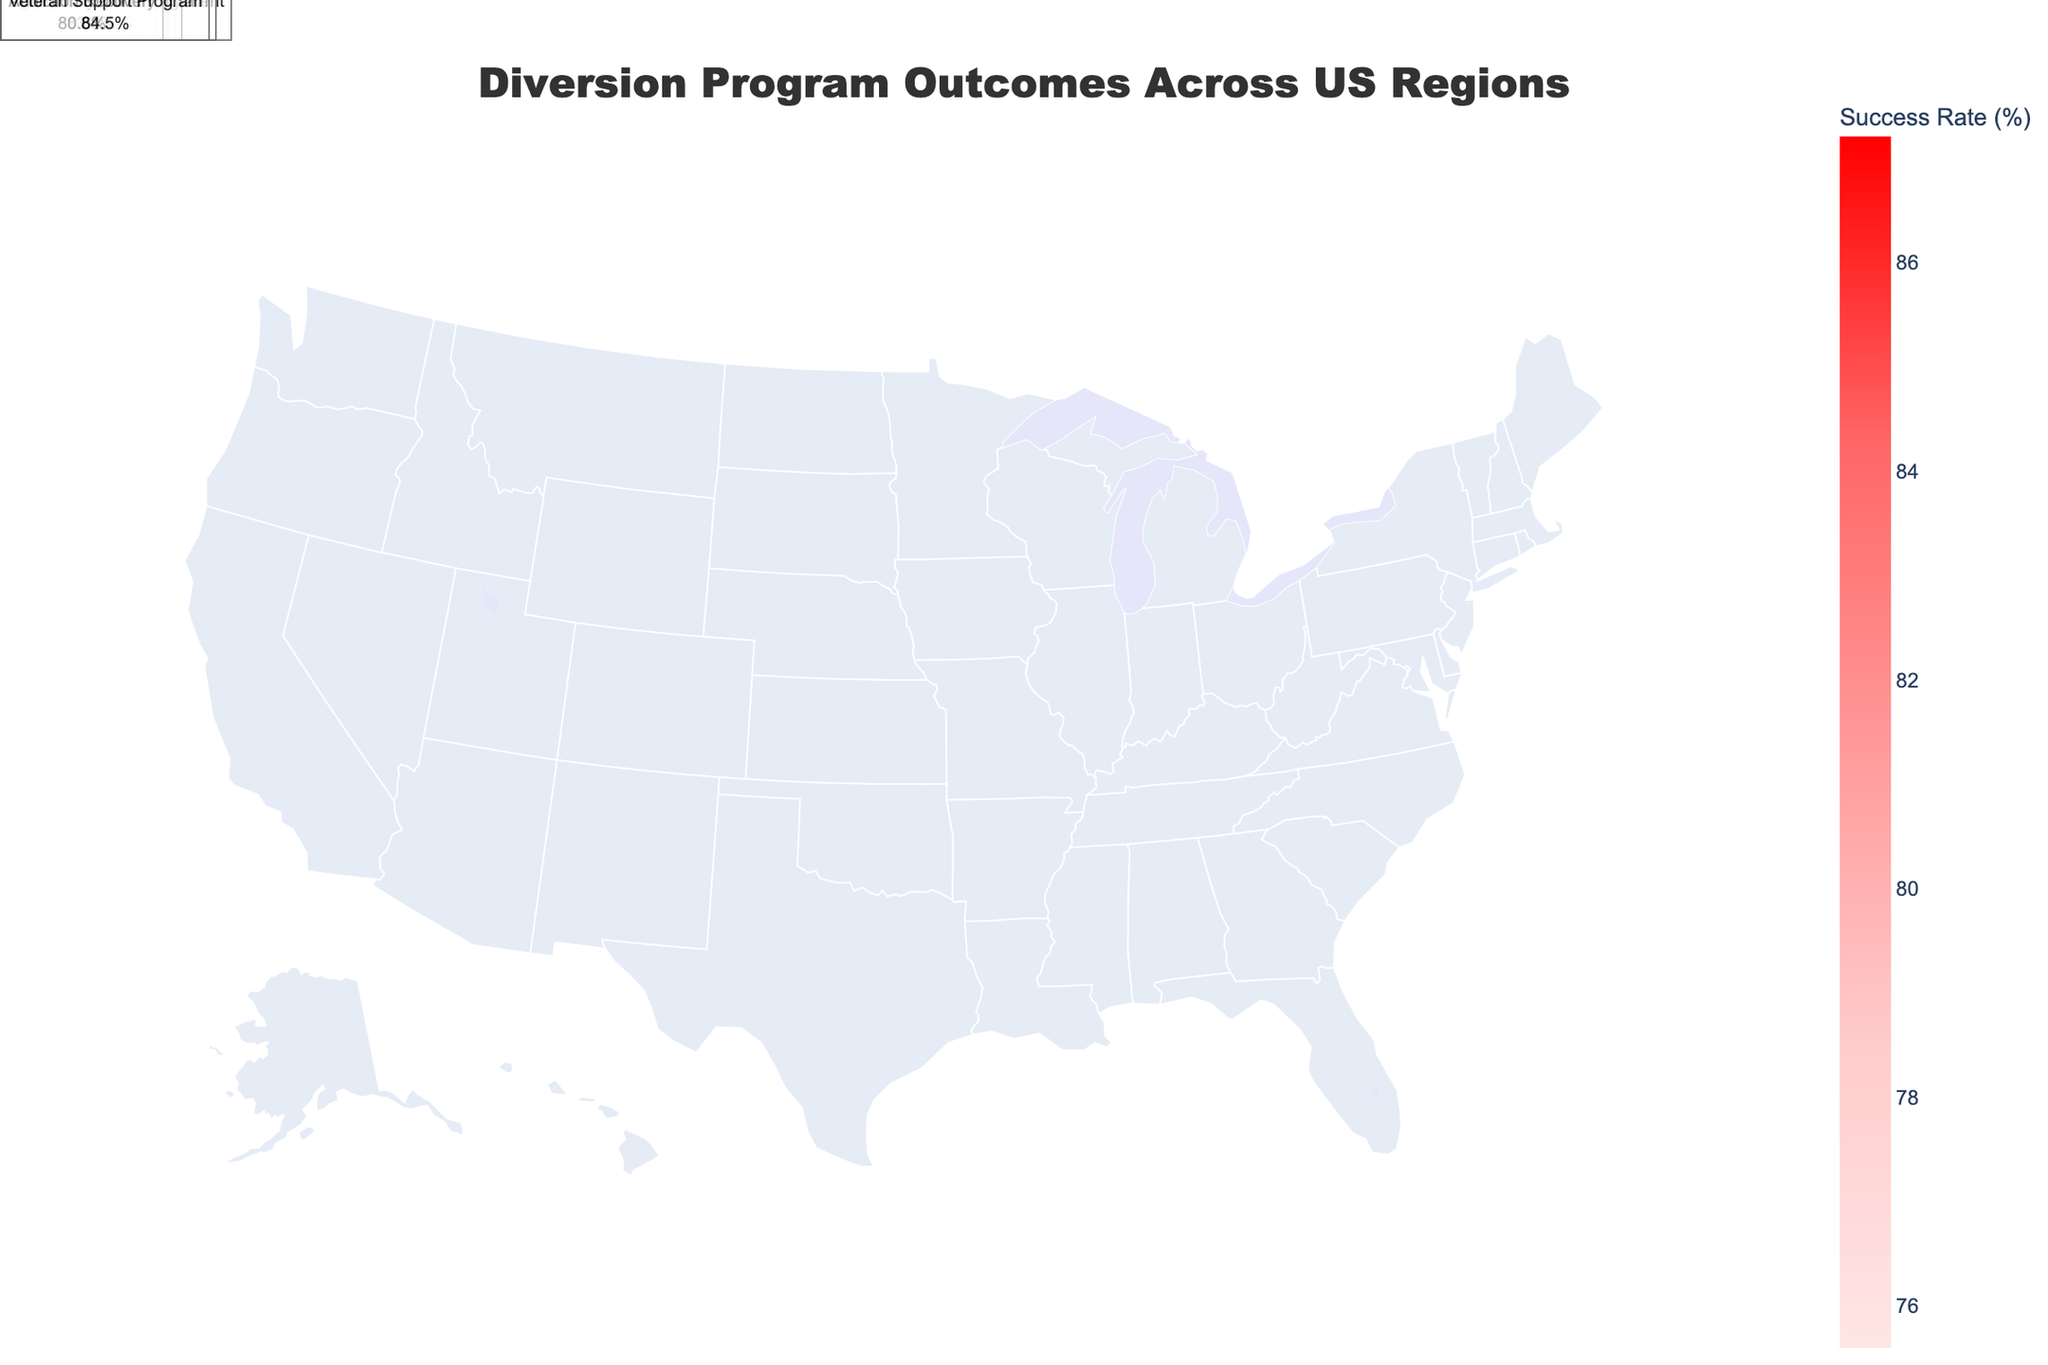Which urban region has the highest success rate for its diversion program? Observe the different urban regions on the map and compare their success rates. Los Angeles has the highest success rate at 82.3%.
Answer: Los Angeles What program in Phoenix has a success rate of 77.9%? Check the label for Phoenix on the map or in the annotations for the stated success rate and corresponding program. It is the Restorative Justice program.
Answer: Restorative Justice Which rural region has the highest success rate for its diversion program? Look through the rural regions and their respective success rates on the map. Aroostook County has the highest success rate at 87.2%.
Answer: Aroostook County What is the combined success rate of Fairfax County and Orange County? Add the success rates of Fairfax County (83.7%) and Orange County (76.5%). 83.7 + 76.5 = 160.2%
Answer: 160.2% How many participants are there in the Addiction Recovery program in Humboldt County? Find Humboldt County on the map and check the annotated details specifically for the Addiction Recovery program. It shows 130 participants.
Answer: 130 Which region has the lowest success rate and what is the associated program? Scan through the regions to identify the one with the lowest success rate. Chicago, with the Mental Health Court program, has a success rate of 75.6%.
Answer: Chicago, Mental Health Court What are the success rates of the diversion programs in New York City and Houston, and which is higher? Compare the rates of New York City (78.5%) and Houston (80.1%). Based on the comparison, Houston has a higher success rate.
Answer: Houston, 80.1% Which has more participants: the Community Service program in New York City or the Drug Treatment program in Los Angeles? Look at the participant numbers for both programs: 1250 (New York City) vs. 980 (Los Angeles). New York City has more participants.
Answer: New York City, 1250 What is the average success rate of the rural regions listed? Calculate the average of the success rates of all rural regions (85.4, 87.2, 83.9, 80.6, 84.5). (85.4 + 87.2 + 83.9 + 80.6 + 84.5) / 5 = 84.32%
Answer: 84.32% Which suburban region has an Anger Management program and how successful is it? Identify the suburban region that offers the Anger Management program, which is Orange County. The success rate is 76.5%.
Answer: Orange County, 76.5% 